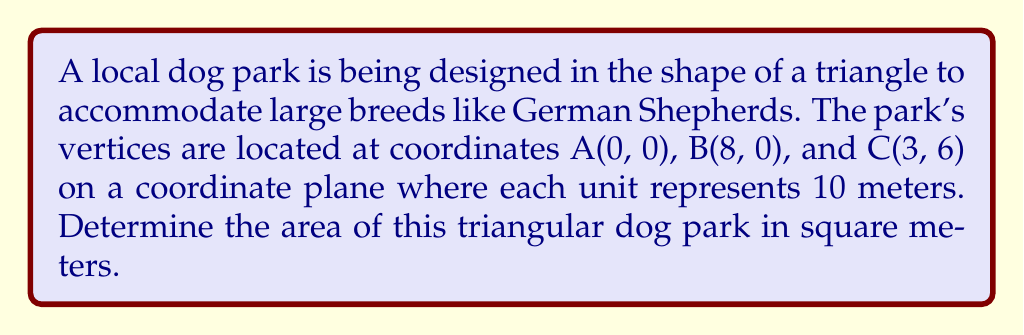Help me with this question. To find the area of the triangular dog park, we can use the formula for the area of a triangle given the coordinates of its vertices. The formula is:

$$\text{Area} = \frac{1}{2}|x_1(y_2 - y_3) + x_2(y_3 - y_1) + x_3(y_1 - y_2)|$$

Where $(x_1, y_1)$, $(x_2, y_2)$, and $(x_3, y_3)$ are the coordinates of the three vertices.

Let's assign our coordinates:
A(0, 0): $x_1 = 0$, $y_1 = 0$
B(8, 0): $x_2 = 8$, $y_2 = 0$
C(3, 6): $x_3 = 3$, $y_3 = 6$

Now, let's substitute these values into the formula:

$$\begin{align*}
\text{Area} &= \frac{1}{2}|0(0 - 6) + 8(6 - 0) + 3(0 - 0)| \\
&= \frac{1}{2}|0 + 48 + 0| \\
&= \frac{1}{2}(48) \\
&= 24
\end{align*}$$

This result is in square units on our coordinate plane. Since each unit represents 10 meters, we need to multiply our result by $10^2 = 100$ to get the area in square meters:

$$24 \times 100 = 2400 \text{ square meters}$$

[asy]
unitsize(1cm);
draw((0,0)--(8,0)--(3,6)--cycle);
label("A(0,0)", (0,0), SW);
label("B(8,0)", (8,0), SE);
label("C(3,6)", (3,6), N);
dot((0,0));
dot((8,0));
dot((3,6));
[/asy]
Answer: The area of the triangular dog park is 2400 square meters. 